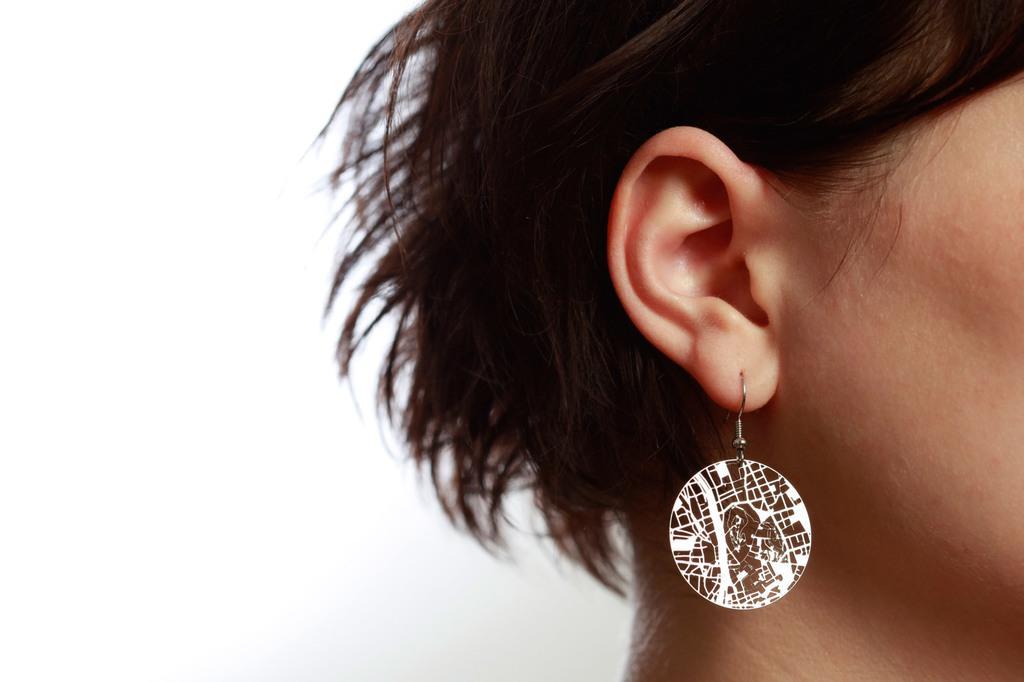How would you summarize this image in a sentence or two? On the right side of this image I can see a person's head and there is an earring to the ear. The background is in white color. 